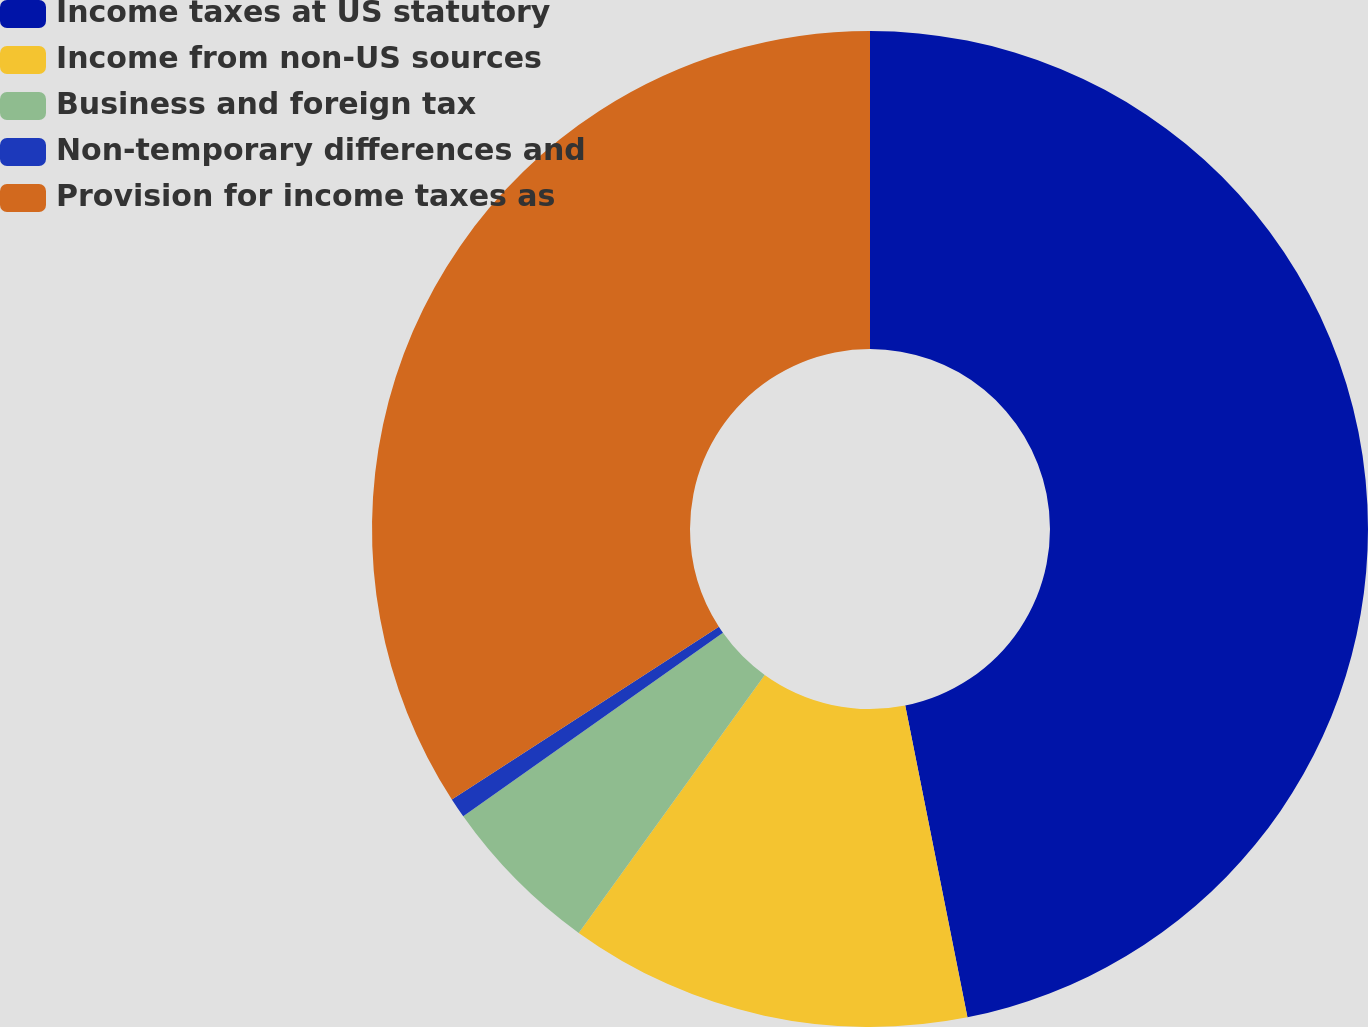<chart> <loc_0><loc_0><loc_500><loc_500><pie_chart><fcel>Income taxes at US statutory<fcel>Income from non-US sources<fcel>Business and foreign tax<fcel>Non-temporary differences and<fcel>Provision for income taxes as<nl><fcel>46.87%<fcel>13.08%<fcel>5.27%<fcel>0.65%<fcel>34.14%<nl></chart> 